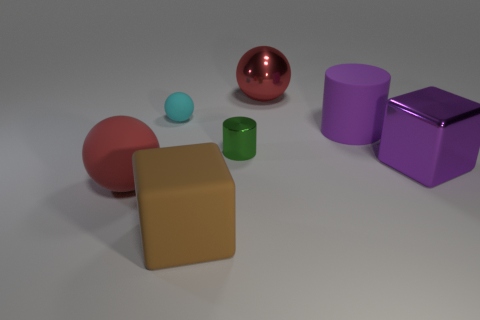Add 2 tiny yellow blocks. How many objects exist? 9 Subtract all cylinders. How many objects are left? 5 Add 1 large purple cylinders. How many large purple cylinders are left? 2 Add 5 red matte blocks. How many red matte blocks exist? 5 Subtract 0 cyan cylinders. How many objects are left? 7 Subtract all cyan rubber balls. Subtract all big matte balls. How many objects are left? 5 